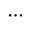<formula> <loc_0><loc_0><loc_500><loc_500>\cdots</formula> 